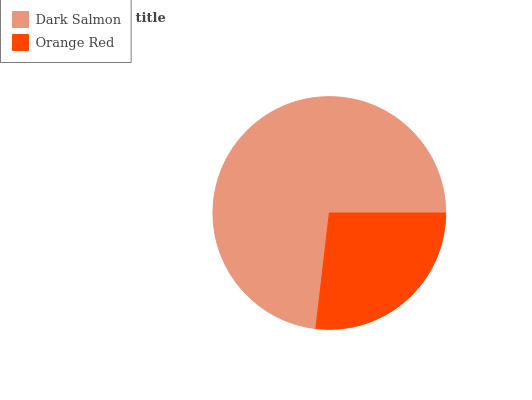Is Orange Red the minimum?
Answer yes or no. Yes. Is Dark Salmon the maximum?
Answer yes or no. Yes. Is Orange Red the maximum?
Answer yes or no. No. Is Dark Salmon greater than Orange Red?
Answer yes or no. Yes. Is Orange Red less than Dark Salmon?
Answer yes or no. Yes. Is Orange Red greater than Dark Salmon?
Answer yes or no. No. Is Dark Salmon less than Orange Red?
Answer yes or no. No. Is Dark Salmon the high median?
Answer yes or no. Yes. Is Orange Red the low median?
Answer yes or no. Yes. Is Orange Red the high median?
Answer yes or no. No. Is Dark Salmon the low median?
Answer yes or no. No. 